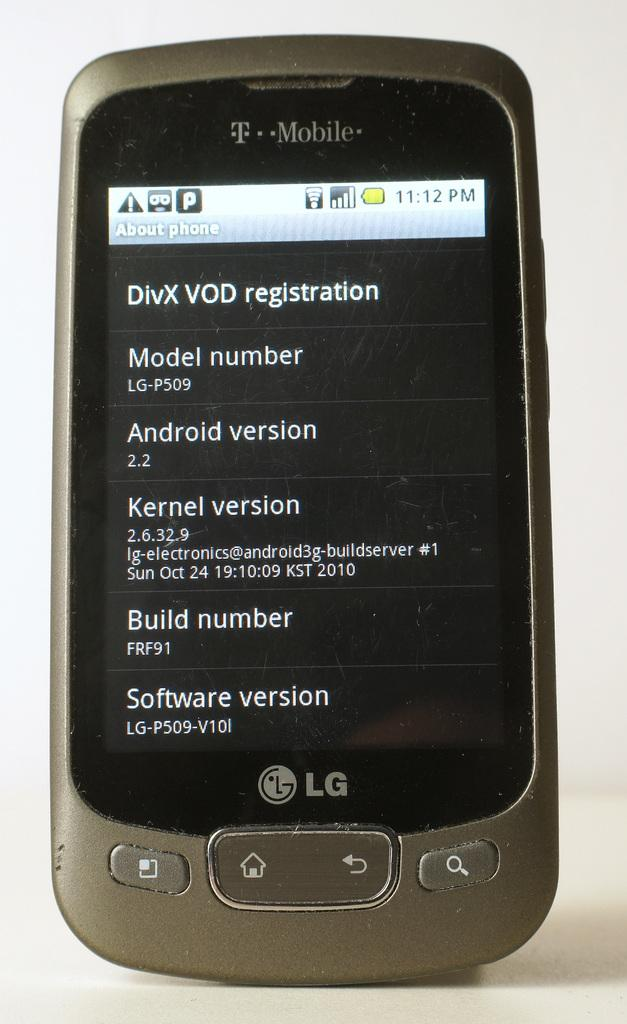<image>
Present a compact description of the photo's key features. a T Mobile cell phone with a screen on DivX Vod registration 